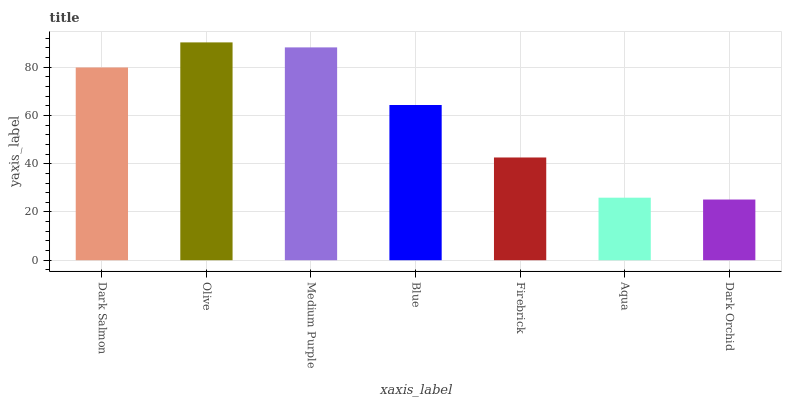Is Dark Orchid the minimum?
Answer yes or no. Yes. Is Olive the maximum?
Answer yes or no. Yes. Is Medium Purple the minimum?
Answer yes or no. No. Is Medium Purple the maximum?
Answer yes or no. No. Is Olive greater than Medium Purple?
Answer yes or no. Yes. Is Medium Purple less than Olive?
Answer yes or no. Yes. Is Medium Purple greater than Olive?
Answer yes or no. No. Is Olive less than Medium Purple?
Answer yes or no. No. Is Blue the high median?
Answer yes or no. Yes. Is Blue the low median?
Answer yes or no. Yes. Is Dark Orchid the high median?
Answer yes or no. No. Is Dark Orchid the low median?
Answer yes or no. No. 